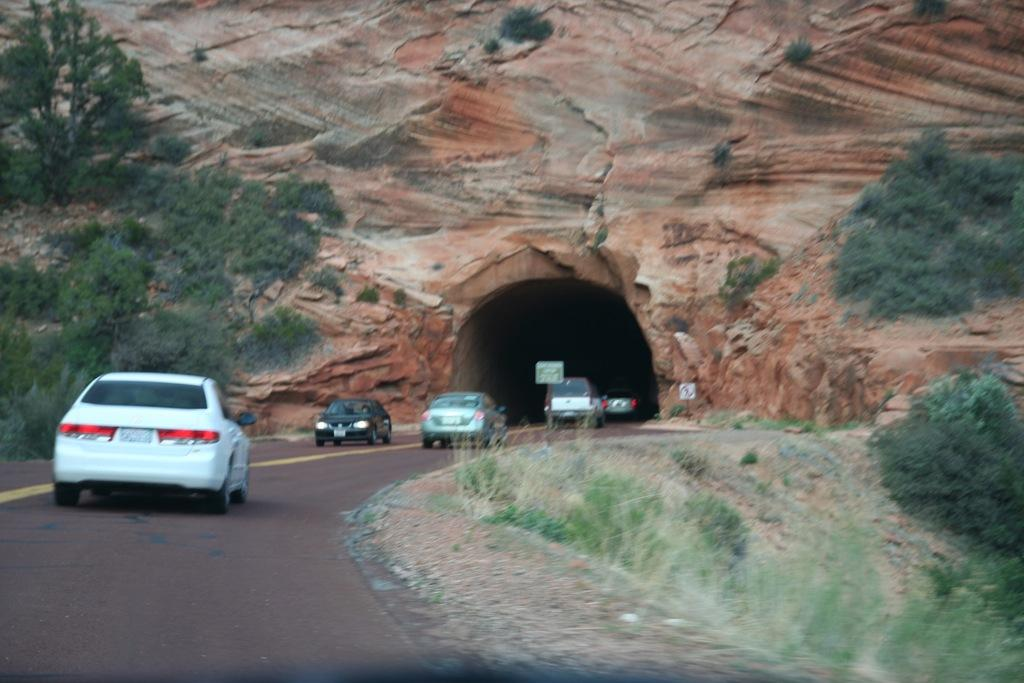What type of vehicles can be seen on the road in the image? There are cars on the road in the image. What can be seen in the background of the image? There are trees and a tunnel visible in the background of the image. How many visitors are present in the image? There is no mention of visitors in the image, as it primarily features cars on the road and the background elements. 